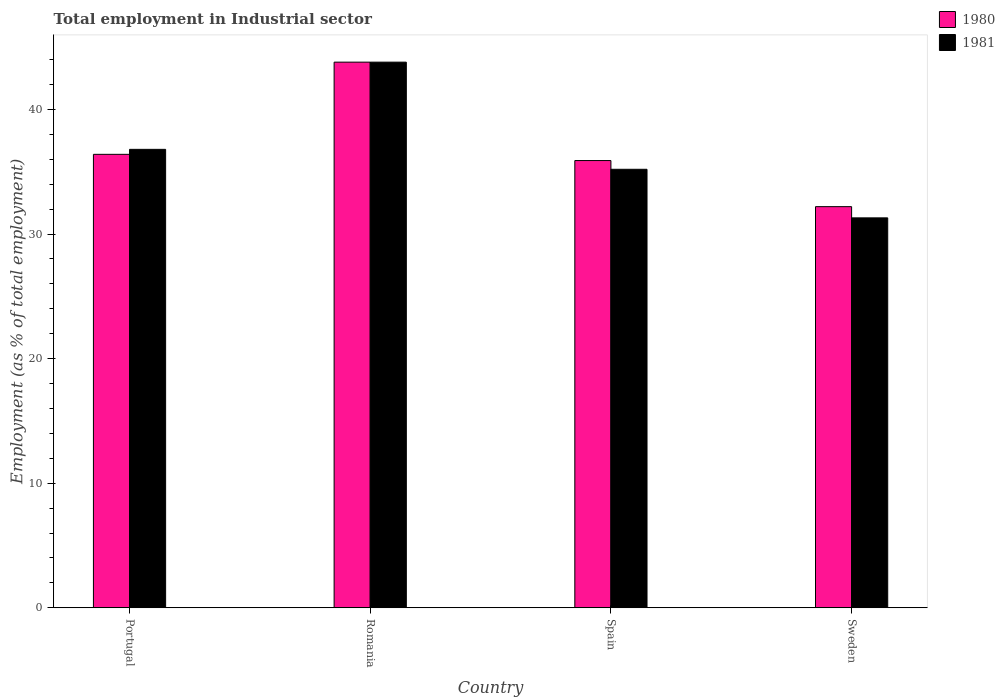How many different coloured bars are there?
Ensure brevity in your answer.  2. How many bars are there on the 3rd tick from the left?
Keep it short and to the point. 2. How many bars are there on the 3rd tick from the right?
Your response must be concise. 2. What is the label of the 1st group of bars from the left?
Give a very brief answer. Portugal. In how many cases, is the number of bars for a given country not equal to the number of legend labels?
Provide a succinct answer. 0. What is the employment in industrial sector in 1980 in Romania?
Offer a very short reply. 43.8. Across all countries, what is the maximum employment in industrial sector in 1980?
Offer a very short reply. 43.8. Across all countries, what is the minimum employment in industrial sector in 1981?
Your answer should be very brief. 31.3. In which country was the employment in industrial sector in 1981 maximum?
Your answer should be very brief. Romania. In which country was the employment in industrial sector in 1980 minimum?
Your response must be concise. Sweden. What is the total employment in industrial sector in 1981 in the graph?
Provide a short and direct response. 147.1. What is the difference between the employment in industrial sector in 1980 in Romania and that in Sweden?
Offer a very short reply. 11.6. What is the difference between the employment in industrial sector in 1980 in Sweden and the employment in industrial sector in 1981 in Portugal?
Provide a succinct answer. -4.6. What is the average employment in industrial sector in 1980 per country?
Give a very brief answer. 37.08. What is the difference between the employment in industrial sector of/in 1981 and employment in industrial sector of/in 1980 in Spain?
Your response must be concise. -0.7. What is the ratio of the employment in industrial sector in 1981 in Portugal to that in Spain?
Ensure brevity in your answer.  1.05. Is the employment in industrial sector in 1980 in Portugal less than that in Spain?
Keep it short and to the point. No. Is the difference between the employment in industrial sector in 1981 in Spain and Sweden greater than the difference between the employment in industrial sector in 1980 in Spain and Sweden?
Offer a terse response. Yes. What is the difference between the highest and the second highest employment in industrial sector in 1981?
Keep it short and to the point. -8.6. What is the difference between the highest and the lowest employment in industrial sector in 1981?
Provide a short and direct response. 12.5. How many bars are there?
Give a very brief answer. 8. Are all the bars in the graph horizontal?
Keep it short and to the point. No. What is the difference between two consecutive major ticks on the Y-axis?
Make the answer very short. 10. Are the values on the major ticks of Y-axis written in scientific E-notation?
Provide a short and direct response. No. Does the graph contain any zero values?
Give a very brief answer. No. Where does the legend appear in the graph?
Offer a very short reply. Top right. How many legend labels are there?
Ensure brevity in your answer.  2. What is the title of the graph?
Make the answer very short. Total employment in Industrial sector. What is the label or title of the Y-axis?
Provide a short and direct response. Employment (as % of total employment). What is the Employment (as % of total employment) in 1980 in Portugal?
Give a very brief answer. 36.4. What is the Employment (as % of total employment) in 1981 in Portugal?
Your answer should be very brief. 36.8. What is the Employment (as % of total employment) of 1980 in Romania?
Your response must be concise. 43.8. What is the Employment (as % of total employment) in 1981 in Romania?
Offer a very short reply. 43.8. What is the Employment (as % of total employment) in 1980 in Spain?
Ensure brevity in your answer.  35.9. What is the Employment (as % of total employment) of 1981 in Spain?
Give a very brief answer. 35.2. What is the Employment (as % of total employment) of 1980 in Sweden?
Your response must be concise. 32.2. What is the Employment (as % of total employment) of 1981 in Sweden?
Your answer should be compact. 31.3. Across all countries, what is the maximum Employment (as % of total employment) in 1980?
Offer a terse response. 43.8. Across all countries, what is the maximum Employment (as % of total employment) in 1981?
Give a very brief answer. 43.8. Across all countries, what is the minimum Employment (as % of total employment) in 1980?
Give a very brief answer. 32.2. Across all countries, what is the minimum Employment (as % of total employment) of 1981?
Give a very brief answer. 31.3. What is the total Employment (as % of total employment) in 1980 in the graph?
Keep it short and to the point. 148.3. What is the total Employment (as % of total employment) of 1981 in the graph?
Give a very brief answer. 147.1. What is the difference between the Employment (as % of total employment) of 1980 in Portugal and that in Spain?
Your response must be concise. 0.5. What is the difference between the Employment (as % of total employment) in 1981 in Portugal and that in Sweden?
Give a very brief answer. 5.5. What is the difference between the Employment (as % of total employment) in 1981 in Romania and that in Spain?
Provide a short and direct response. 8.6. What is the difference between the Employment (as % of total employment) of 1980 in Spain and that in Sweden?
Give a very brief answer. 3.7. What is the difference between the Employment (as % of total employment) in 1981 in Spain and that in Sweden?
Your answer should be very brief. 3.9. What is the difference between the Employment (as % of total employment) in 1980 in Portugal and the Employment (as % of total employment) in 1981 in Romania?
Provide a short and direct response. -7.4. What is the average Employment (as % of total employment) of 1980 per country?
Offer a very short reply. 37.08. What is the average Employment (as % of total employment) in 1981 per country?
Keep it short and to the point. 36.77. What is the difference between the Employment (as % of total employment) in 1980 and Employment (as % of total employment) in 1981 in Romania?
Provide a short and direct response. 0. What is the difference between the Employment (as % of total employment) of 1980 and Employment (as % of total employment) of 1981 in Spain?
Provide a short and direct response. 0.7. What is the ratio of the Employment (as % of total employment) of 1980 in Portugal to that in Romania?
Keep it short and to the point. 0.83. What is the ratio of the Employment (as % of total employment) in 1981 in Portugal to that in Romania?
Make the answer very short. 0.84. What is the ratio of the Employment (as % of total employment) in 1980 in Portugal to that in Spain?
Offer a very short reply. 1.01. What is the ratio of the Employment (as % of total employment) in 1981 in Portugal to that in Spain?
Your answer should be very brief. 1.05. What is the ratio of the Employment (as % of total employment) of 1980 in Portugal to that in Sweden?
Your response must be concise. 1.13. What is the ratio of the Employment (as % of total employment) in 1981 in Portugal to that in Sweden?
Your answer should be very brief. 1.18. What is the ratio of the Employment (as % of total employment) of 1980 in Romania to that in Spain?
Provide a short and direct response. 1.22. What is the ratio of the Employment (as % of total employment) of 1981 in Romania to that in Spain?
Make the answer very short. 1.24. What is the ratio of the Employment (as % of total employment) in 1980 in Romania to that in Sweden?
Your answer should be compact. 1.36. What is the ratio of the Employment (as % of total employment) of 1981 in Romania to that in Sweden?
Keep it short and to the point. 1.4. What is the ratio of the Employment (as % of total employment) of 1980 in Spain to that in Sweden?
Your response must be concise. 1.11. What is the ratio of the Employment (as % of total employment) in 1981 in Spain to that in Sweden?
Keep it short and to the point. 1.12. What is the difference between the highest and the second highest Employment (as % of total employment) of 1981?
Make the answer very short. 7. What is the difference between the highest and the lowest Employment (as % of total employment) of 1980?
Offer a very short reply. 11.6. 